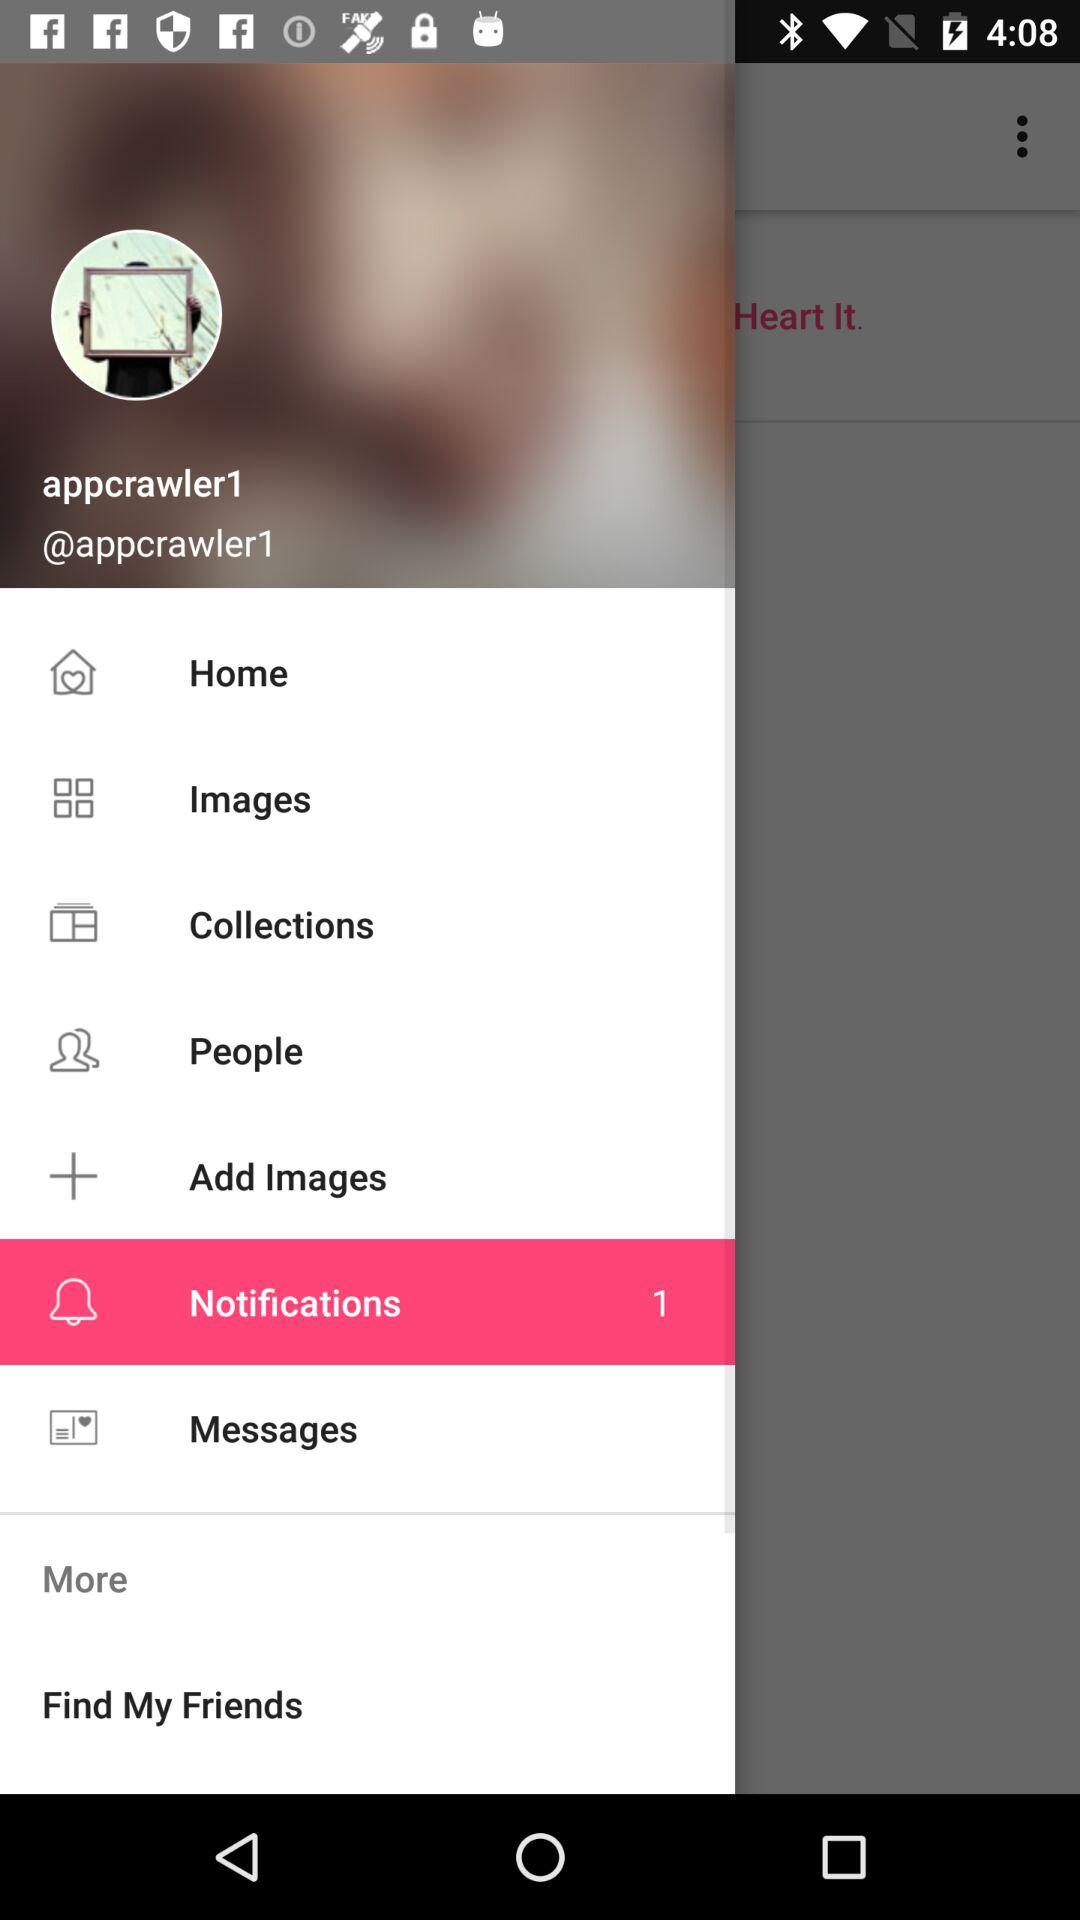What is the username? The username is "appcrawler1". 